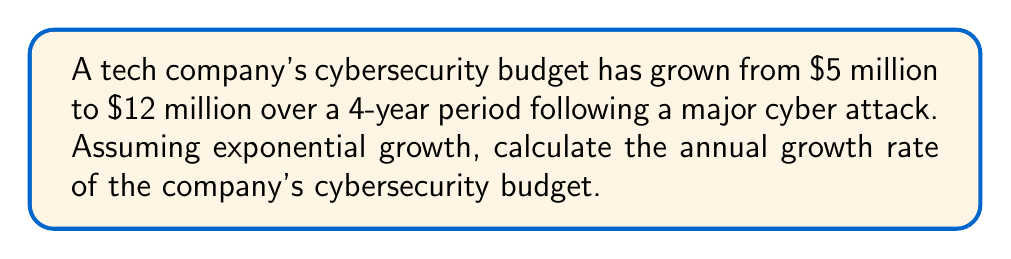Can you answer this question? To solve this problem, we'll use the exponential growth formula:

$$A = P(1 + r)^t$$

Where:
$A$ = Final amount ($12 million)
$P$ = Initial amount ($5 million)
$r$ = Annual growth rate (to be calculated)
$t$ = Time period (4 years)

Step 1: Substitute the known values into the formula:
$$12 = 5(1 + r)^4$$

Step 2: Divide both sides by 5:
$$\frac{12}{5} = (1 + r)^4$$

Step 3: Take the fourth root of both sides:
$$\sqrt[4]{\frac{12}{5}} = 1 + r$$

Step 4: Subtract 1 from both sides:
$$\sqrt[4]{\frac{12}{5}} - 1 = r$$

Step 5: Calculate the value:
$$r = \sqrt[4]{2.4} - 1 \approx 1.2457 - 1 = 0.2457$$

Step 6: Convert to percentage:
$$r \approx 0.2457 \times 100\% = 24.57\%$$
Answer: 24.57% 